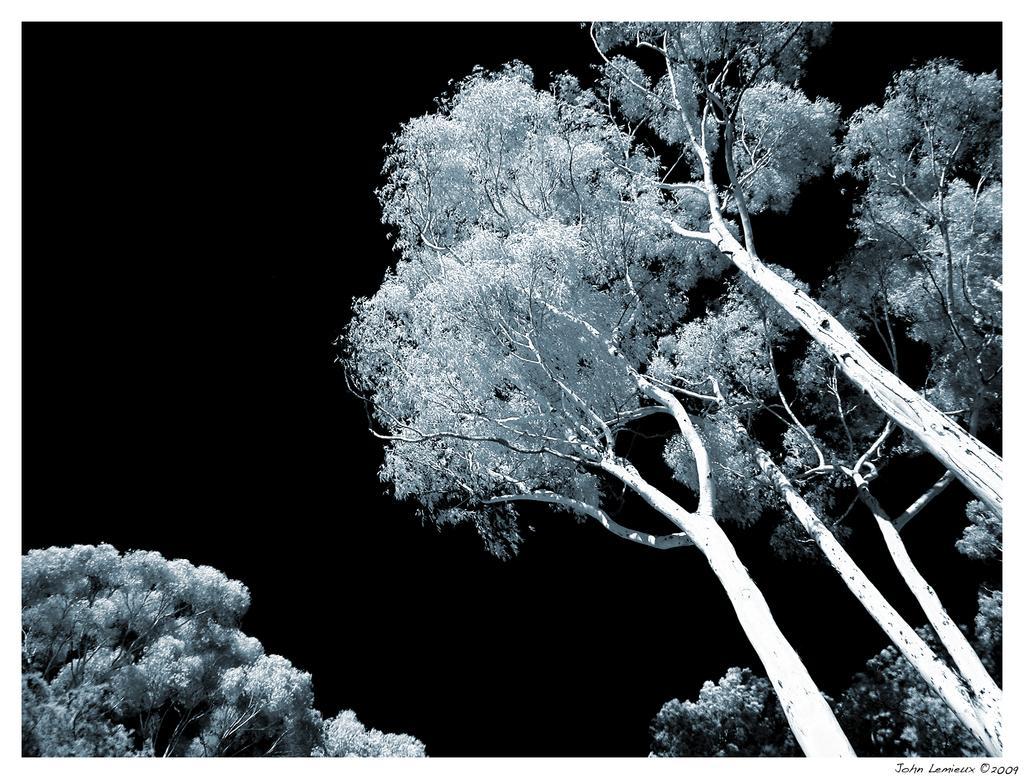Please provide a concise description of this image. In this picture I can see few trees, looks like this picture is taken in the dark. 